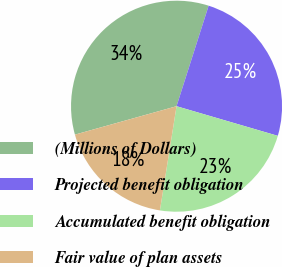<chart> <loc_0><loc_0><loc_500><loc_500><pie_chart><fcel>(Millions of Dollars)<fcel>Projected benefit obligation<fcel>Accumulated benefit obligation<fcel>Fair value of plan assets<nl><fcel>34.26%<fcel>24.61%<fcel>22.99%<fcel>18.14%<nl></chart> 